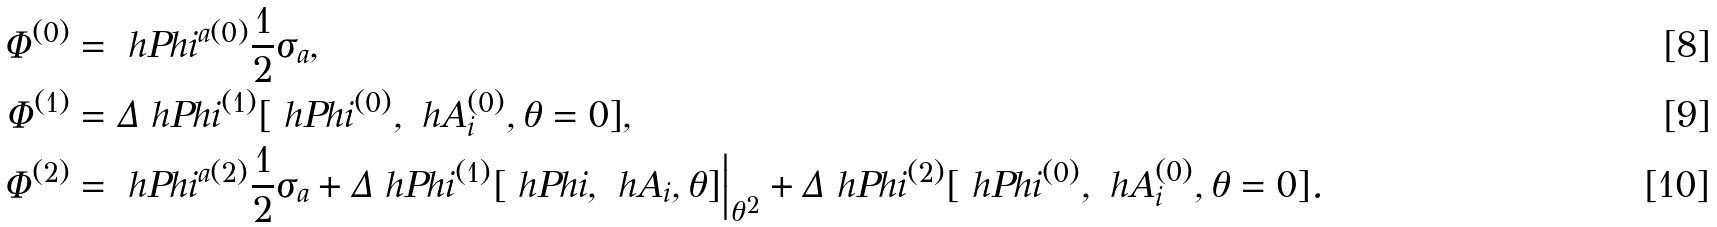<formula> <loc_0><loc_0><loc_500><loc_500>\Phi ^ { ( 0 ) } & = \ h P h i ^ { a ( 0 ) } \frac { 1 } { 2 } \sigma _ { a } , \\ \Phi ^ { ( 1 ) } & = \Delta \ h P h i ^ { ( 1 ) } [ \ h P h i ^ { ( 0 ) } , \ h A _ { i } ^ { ( 0 ) } , \theta = 0 ] , \\ \Phi ^ { ( 2 ) } & = \ h P h i ^ { a ( 2 ) } \frac { 1 } { 2 } \sigma _ { a } + \Delta \ h P h i ^ { ( 1 ) } [ \ h P h i , \ h A _ { i } , \theta ] \Big | _ { \theta ^ { 2 } } + \Delta \ h P h i ^ { ( 2 ) } [ \ h P h i ^ { ( 0 ) } , \ h A _ { i } ^ { ( 0 ) } , \theta = 0 ] .</formula> 